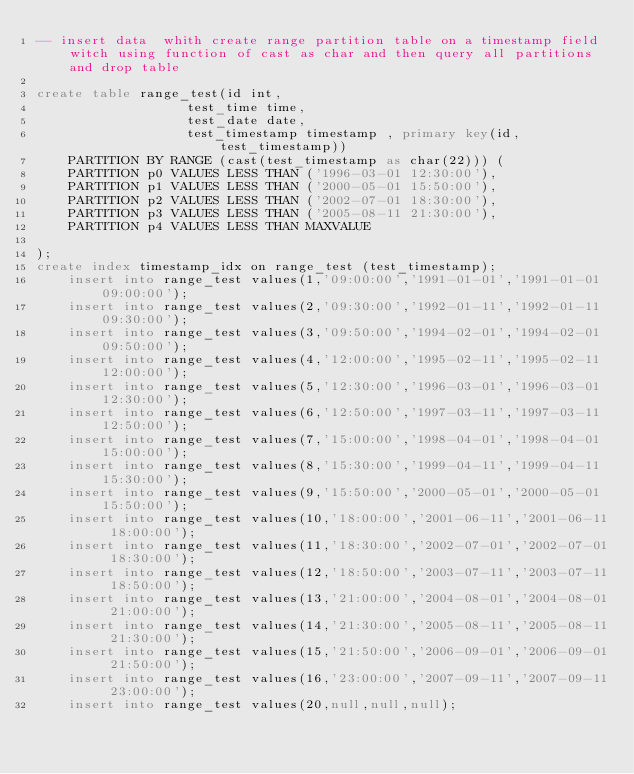Convert code to text. <code><loc_0><loc_0><loc_500><loc_500><_SQL_>-- insert data  whith create range partition table on a timestamp field witch using function of cast as char and then query all partitions and drop table

create table range_test(id int,	
				   test_time time,
				   test_date date,
				   test_timestamp timestamp , primary key(id,test_timestamp))
	PARTITION BY RANGE (cast(test_timestamp as char(22))) (
	PARTITION p0 VALUES LESS THAN ('1996-03-01 12:30:00'),
	PARTITION p1 VALUES LESS THAN ('2000-05-01 15:50:00'),
	PARTITION p2 VALUES LESS THAN ('2002-07-01 18:30:00'),
	PARTITION p3 VALUES LESS THAN ('2005-08-11 21:30:00'),
	PARTITION p4 VALUES LESS THAN MAXVALUE

);
create index timestamp_idx on range_test (test_timestamp);
	insert into range_test values(1,'09:00:00','1991-01-01','1991-01-01 09:00:00');
	insert into range_test values(2,'09:30:00','1992-01-11','1992-01-11 09:30:00');
	insert into range_test values(3,'09:50:00','1994-02-01','1994-02-01 09:50:00');
	insert into range_test values(4,'12:00:00','1995-02-11','1995-02-11 12:00:00');
	insert into range_test values(5,'12:30:00','1996-03-01','1996-03-01 12:30:00');
	insert into range_test values(6,'12:50:00','1997-03-11','1997-03-11 12:50:00');
	insert into range_test values(7,'15:00:00','1998-04-01','1998-04-01 15:00:00');
	insert into range_test values(8,'15:30:00','1999-04-11','1999-04-11 15:30:00');
	insert into range_test values(9,'15:50:00','2000-05-01','2000-05-01 15:50:00');
	insert into range_test values(10,'18:00:00','2001-06-11','2001-06-11 18:00:00');
	insert into range_test values(11,'18:30:00','2002-07-01','2002-07-01 18:30:00');
	insert into range_test values(12,'18:50:00','2003-07-11','2003-07-11 18:50:00');
	insert into range_test values(13,'21:00:00','2004-08-01','2004-08-01 21:00:00');
	insert into range_test values(14,'21:30:00','2005-08-11','2005-08-11 21:30:00');
	insert into range_test values(15,'21:50:00','2006-09-01','2006-09-01 21:50:00');
	insert into range_test values(16,'23:00:00','2007-09-11','2007-09-11 23:00:00');	
	insert into range_test values(20,null,null,null);
</code> 